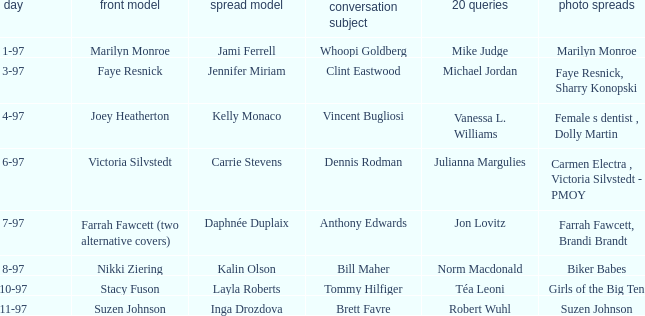When was Kalin Olson listed as  the centerfold model? 8-97. 